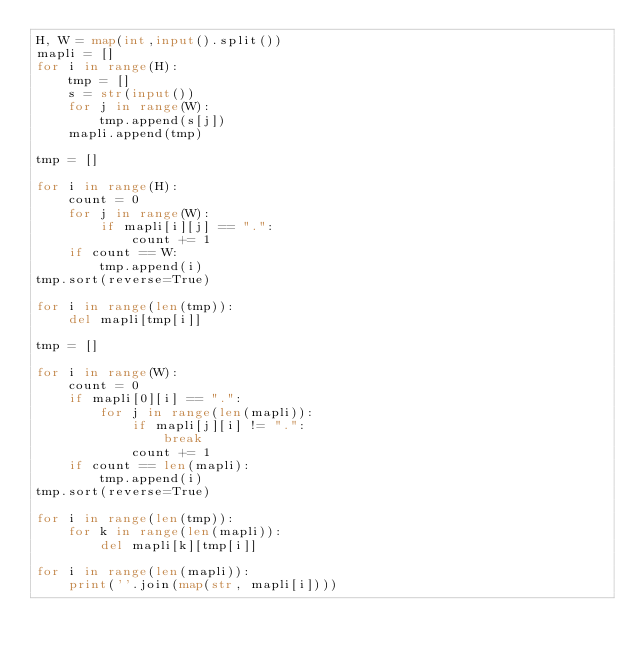Convert code to text. <code><loc_0><loc_0><loc_500><loc_500><_Python_>H, W = map(int,input().split())
mapli = []
for i in range(H):
    tmp = []
    s = str(input())
    for j in range(W):
        tmp.append(s[j])
    mapli.append(tmp)

tmp = []

for i in range(H):
    count = 0
    for j in range(W):
        if mapli[i][j] == ".":
            count += 1
    if count == W:
        tmp.append(i)
tmp.sort(reverse=True)

for i in range(len(tmp)):
    del mapli[tmp[i]]

tmp = []

for i in range(W):
    count = 0 
    if mapli[0][i] == ".": 
        for j in range(len(mapli)):
            if mapli[j][i] != ".":
                break
            count += 1
    if count == len(mapli):
        tmp.append(i)
tmp.sort(reverse=True)

for i in range(len(tmp)):
    for k in range(len(mapli)):
        del mapli[k][tmp[i]]

for i in range(len(mapli)):
    print(''.join(map(str, mapli[i])))
</code> 